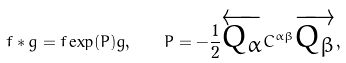Convert formula to latex. <formula><loc_0><loc_0><loc_500><loc_500>f * g = f \exp ( P ) g , \quad P = - \frac { 1 } { 2 } \overleftarrow { Q _ { \alpha } } C ^ { \alpha \beta } \overrightarrow { Q _ { \beta } } ,</formula> 